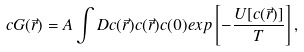<formula> <loc_0><loc_0><loc_500><loc_500>c G ( \vec { r } ) = A \int D c ( \vec { r } ) c ( \vec { r } ) c ( 0 ) e x p \left [ - \frac { U [ c ( \vec { r } ) ] } { T } \right ] ,</formula> 